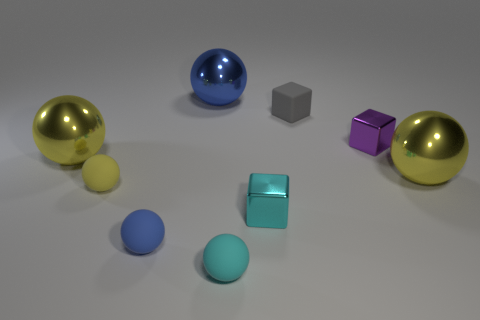Subtract all green blocks. How many blue balls are left? 2 Subtract 4 spheres. How many spheres are left? 2 Subtract all tiny blue balls. How many balls are left? 5 Subtract all blue balls. How many balls are left? 4 Subtract all gray spheres. Subtract all gray cubes. How many spheres are left? 6 Subtract all blocks. How many objects are left? 6 Subtract all large gray rubber balls. Subtract all tiny cyan rubber spheres. How many objects are left? 8 Add 2 small cyan rubber objects. How many small cyan rubber objects are left? 3 Add 9 brown metallic cylinders. How many brown metallic cylinders exist? 9 Subtract 0 blue cylinders. How many objects are left? 9 